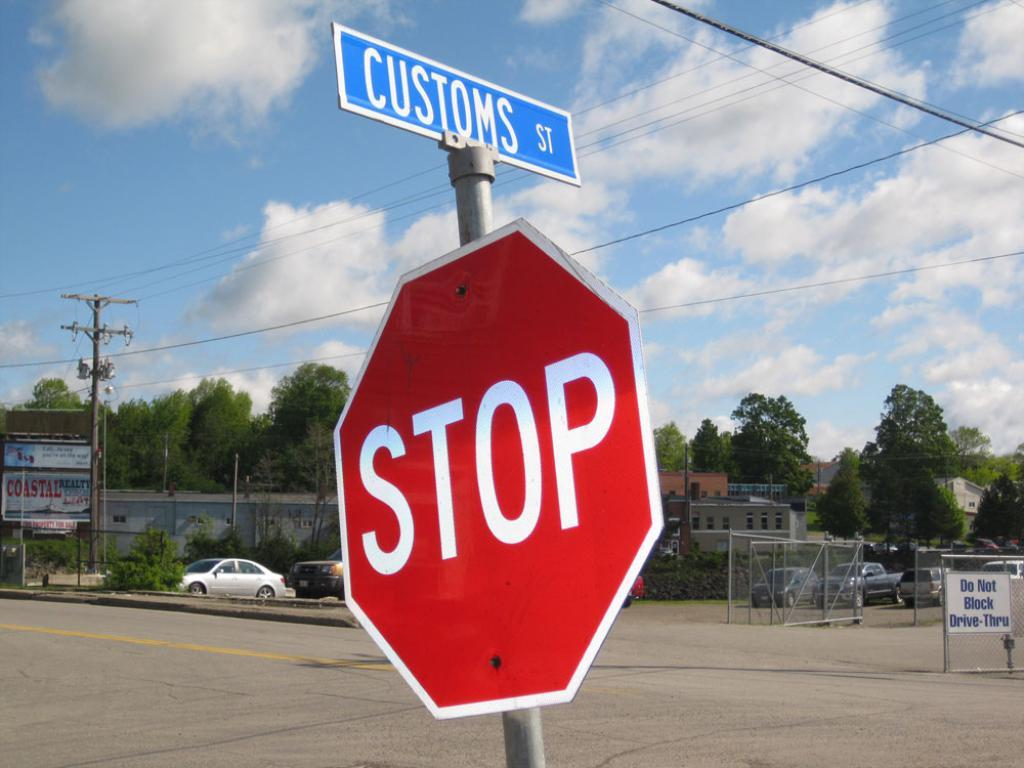Provide a one-sentence caption for the provided image. A blue street sign for Customs Street is mounted above a red stop sign. 